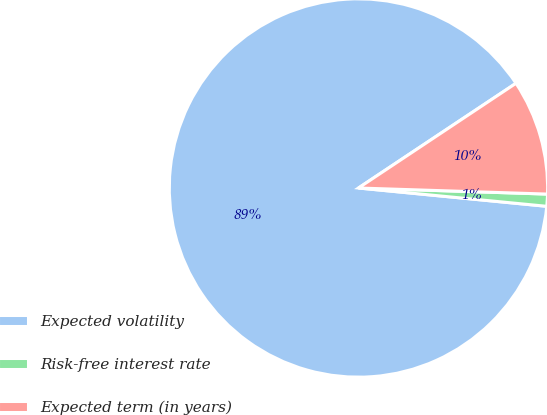Convert chart to OTSL. <chart><loc_0><loc_0><loc_500><loc_500><pie_chart><fcel>Expected volatility<fcel>Risk-free interest rate<fcel>Expected term (in years)<nl><fcel>89.12%<fcel>1.03%<fcel>9.85%<nl></chart> 